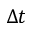<formula> <loc_0><loc_0><loc_500><loc_500>\Delta t</formula> 